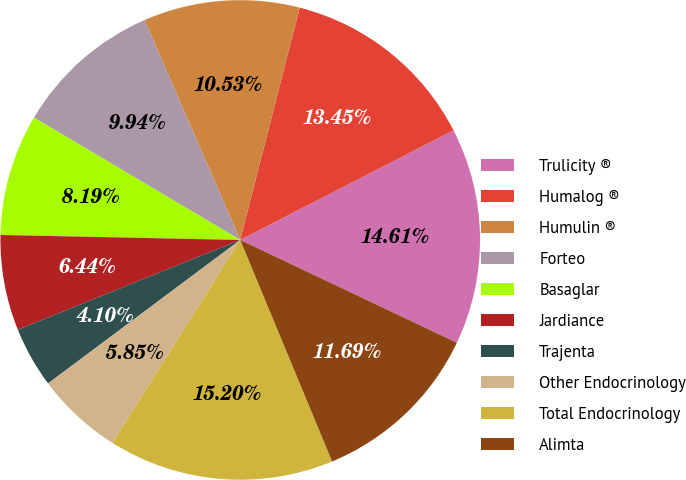<chart> <loc_0><loc_0><loc_500><loc_500><pie_chart><fcel>Trulicity ®<fcel>Humalog ®<fcel>Humulin ®<fcel>Forteo<fcel>Basaglar<fcel>Jardiance<fcel>Trajenta<fcel>Other Endocrinology<fcel>Total Endocrinology<fcel>Alimta<nl><fcel>14.61%<fcel>13.45%<fcel>10.53%<fcel>9.94%<fcel>8.19%<fcel>6.44%<fcel>4.1%<fcel>5.85%<fcel>15.2%<fcel>11.69%<nl></chart> 